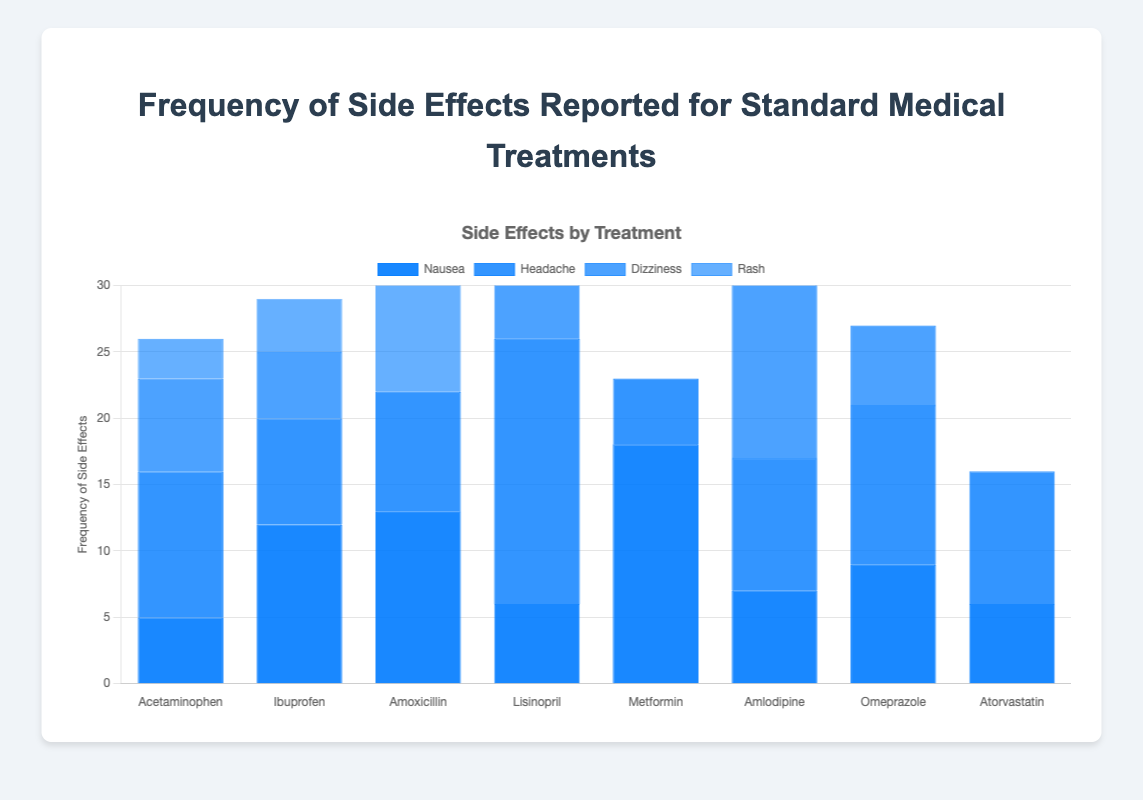What is the most frequently reported side effect for Ibuprofen? The side effect frequency data for Ibuprofen shows that "Stomach pain" has a count of 15. Comparing it with "Nausea" (12), "Headache" (8), "Dizziness" (5), and "Rash" (4), it is clear that "Stomach pain" has the highest count.
Answer: Stomach pain Which treatment has the highest frequency of reported "Diarrhea"? The datasets for "Diarrhea" are: "Amoxicillin" (20) and "Metformin" (25). Since 25 is greater than 20, "Metformin" has the highest frequency.
Answer: Metformin How many total side effects are reported for Amlodipine? Summing up the side effects of "Amlodipine": Nausea (7) + Headache (10) + Dizziness (15) + Swelling (12). The total is 7 + 10 + 15 + 12 = 44.
Answer: 44 Compare the frequency of "Headache" for Acetaminophen and Lisinopril. Which has more reported cases? The frequency of "Headache" for Acetaminophen is 11, and for Lisinopril, it is 20. Comparing these numbers, Lisinopril has more reported cases.
Answer: Lisinopril Which treatment has the least reported "Nausea"? The "Nausea" counts are: Acetaminophen (5), Ibuprofen (12), Amoxicillin (13), Lisinopril (6), Metformin (18), Amlodipine (7), Omeprazole (9), and Atorvastatin (6). The least is for Acetaminophen with 5.
Answer: Acetaminophen For which treatment does "Dizziness" appear most frequently? Checking the frequency: Acetaminophen (7), Ibuprofen (5), Lisinopril (14), Amlodipine (15), Omeprazole (6), "Dizziness" appears most frequently with Amlodipine at 15.
Answer: Amlodipine What is the difference in the frequency of "Fatigue" between Metformin and Atorvastatin? "Fatigue" for Metformin is 7 and for Atorvastatin is 14. The difference is 14 - 7 = 7.
Answer: 7 How many treatments report "Rash" as a side effect? The side effect data shows the following for "Rash": Acetaminophen, Ibuprofen, and Amoxicillin. Therefore, it's reported in 3 treatments.
Answer: 3 What is the average frequency of "Headache" across all treatments? Frequencies for "Headache": Acetaminophen (11), Ibuprofen (8), Amoxicillin (9), Lisinopril (20), Metformin (5), Amlodipine (10), Omeprazole (12), Atorvastatin (10). Summing them: 85. There are 8 treatments, so the average is 85/8 = 10.625.
Answer: 10.625 